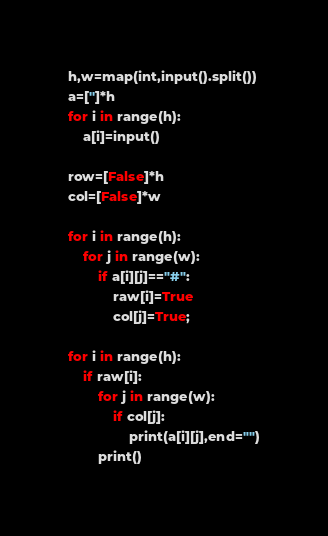Convert code to text. <code><loc_0><loc_0><loc_500><loc_500><_Python_>h,w=map(int,input().split())
a=['']*h
for i in range(h):
    a[i]=input()

row=[False]*h
col=[False]*w

for i in range(h):
    for j in range(w):
        if a[i][j]=="#":
            raw[i]=True
            col[j]=True;

for i in range(h):
    if raw[i]:
        for j in range(w):
            if col[j]:
                print(a[i][j],end="")
        print()
</code> 